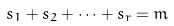Convert formula to latex. <formula><loc_0><loc_0><loc_500><loc_500>s _ { 1 } + s _ { 2 } + \dots + s _ { r } = m</formula> 